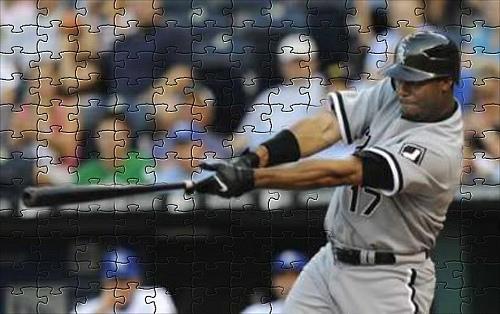What sport is the person playing?
Keep it brief. Baseball. Is this a photo?
Short answer required. Yes. Is this a picture of a puzzle?
Write a very short answer. Puzzle. 